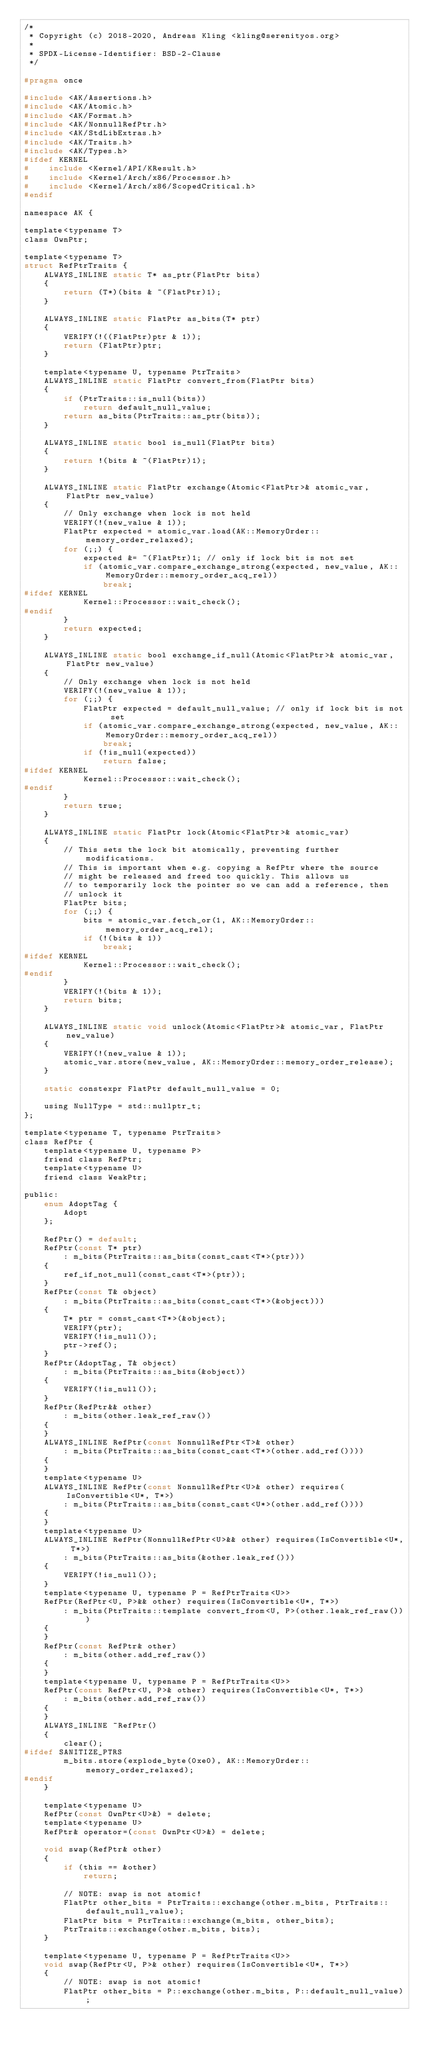Convert code to text. <code><loc_0><loc_0><loc_500><loc_500><_C_>/*
 * Copyright (c) 2018-2020, Andreas Kling <kling@serenityos.org>
 *
 * SPDX-License-Identifier: BSD-2-Clause
 */

#pragma once

#include <AK/Assertions.h>
#include <AK/Atomic.h>
#include <AK/Format.h>
#include <AK/NonnullRefPtr.h>
#include <AK/StdLibExtras.h>
#include <AK/Traits.h>
#include <AK/Types.h>
#ifdef KERNEL
#    include <Kernel/API/KResult.h>
#    include <Kernel/Arch/x86/Processor.h>
#    include <Kernel/Arch/x86/ScopedCritical.h>
#endif

namespace AK {

template<typename T>
class OwnPtr;

template<typename T>
struct RefPtrTraits {
    ALWAYS_INLINE static T* as_ptr(FlatPtr bits)
    {
        return (T*)(bits & ~(FlatPtr)1);
    }

    ALWAYS_INLINE static FlatPtr as_bits(T* ptr)
    {
        VERIFY(!((FlatPtr)ptr & 1));
        return (FlatPtr)ptr;
    }

    template<typename U, typename PtrTraits>
    ALWAYS_INLINE static FlatPtr convert_from(FlatPtr bits)
    {
        if (PtrTraits::is_null(bits))
            return default_null_value;
        return as_bits(PtrTraits::as_ptr(bits));
    }

    ALWAYS_INLINE static bool is_null(FlatPtr bits)
    {
        return !(bits & ~(FlatPtr)1);
    }

    ALWAYS_INLINE static FlatPtr exchange(Atomic<FlatPtr>& atomic_var, FlatPtr new_value)
    {
        // Only exchange when lock is not held
        VERIFY(!(new_value & 1));
        FlatPtr expected = atomic_var.load(AK::MemoryOrder::memory_order_relaxed);
        for (;;) {
            expected &= ~(FlatPtr)1; // only if lock bit is not set
            if (atomic_var.compare_exchange_strong(expected, new_value, AK::MemoryOrder::memory_order_acq_rel))
                break;
#ifdef KERNEL
            Kernel::Processor::wait_check();
#endif
        }
        return expected;
    }

    ALWAYS_INLINE static bool exchange_if_null(Atomic<FlatPtr>& atomic_var, FlatPtr new_value)
    {
        // Only exchange when lock is not held
        VERIFY(!(new_value & 1));
        for (;;) {
            FlatPtr expected = default_null_value; // only if lock bit is not set
            if (atomic_var.compare_exchange_strong(expected, new_value, AK::MemoryOrder::memory_order_acq_rel))
                break;
            if (!is_null(expected))
                return false;
#ifdef KERNEL
            Kernel::Processor::wait_check();
#endif
        }
        return true;
    }

    ALWAYS_INLINE static FlatPtr lock(Atomic<FlatPtr>& atomic_var)
    {
        // This sets the lock bit atomically, preventing further modifications.
        // This is important when e.g. copying a RefPtr where the source
        // might be released and freed too quickly. This allows us
        // to temporarily lock the pointer so we can add a reference, then
        // unlock it
        FlatPtr bits;
        for (;;) {
            bits = atomic_var.fetch_or(1, AK::MemoryOrder::memory_order_acq_rel);
            if (!(bits & 1))
                break;
#ifdef KERNEL
            Kernel::Processor::wait_check();
#endif
        }
        VERIFY(!(bits & 1));
        return bits;
    }

    ALWAYS_INLINE static void unlock(Atomic<FlatPtr>& atomic_var, FlatPtr new_value)
    {
        VERIFY(!(new_value & 1));
        atomic_var.store(new_value, AK::MemoryOrder::memory_order_release);
    }

    static constexpr FlatPtr default_null_value = 0;

    using NullType = std::nullptr_t;
};

template<typename T, typename PtrTraits>
class RefPtr {
    template<typename U, typename P>
    friend class RefPtr;
    template<typename U>
    friend class WeakPtr;

public:
    enum AdoptTag {
        Adopt
    };

    RefPtr() = default;
    RefPtr(const T* ptr)
        : m_bits(PtrTraits::as_bits(const_cast<T*>(ptr)))
    {
        ref_if_not_null(const_cast<T*>(ptr));
    }
    RefPtr(const T& object)
        : m_bits(PtrTraits::as_bits(const_cast<T*>(&object)))
    {
        T* ptr = const_cast<T*>(&object);
        VERIFY(ptr);
        VERIFY(!is_null());
        ptr->ref();
    }
    RefPtr(AdoptTag, T& object)
        : m_bits(PtrTraits::as_bits(&object))
    {
        VERIFY(!is_null());
    }
    RefPtr(RefPtr&& other)
        : m_bits(other.leak_ref_raw())
    {
    }
    ALWAYS_INLINE RefPtr(const NonnullRefPtr<T>& other)
        : m_bits(PtrTraits::as_bits(const_cast<T*>(other.add_ref())))
    {
    }
    template<typename U>
    ALWAYS_INLINE RefPtr(const NonnullRefPtr<U>& other) requires(IsConvertible<U*, T*>)
        : m_bits(PtrTraits::as_bits(const_cast<U*>(other.add_ref())))
    {
    }
    template<typename U>
    ALWAYS_INLINE RefPtr(NonnullRefPtr<U>&& other) requires(IsConvertible<U*, T*>)
        : m_bits(PtrTraits::as_bits(&other.leak_ref()))
    {
        VERIFY(!is_null());
    }
    template<typename U, typename P = RefPtrTraits<U>>
    RefPtr(RefPtr<U, P>&& other) requires(IsConvertible<U*, T*>)
        : m_bits(PtrTraits::template convert_from<U, P>(other.leak_ref_raw()))
    {
    }
    RefPtr(const RefPtr& other)
        : m_bits(other.add_ref_raw())
    {
    }
    template<typename U, typename P = RefPtrTraits<U>>
    RefPtr(const RefPtr<U, P>& other) requires(IsConvertible<U*, T*>)
        : m_bits(other.add_ref_raw())
    {
    }
    ALWAYS_INLINE ~RefPtr()
    {
        clear();
#ifdef SANITIZE_PTRS
        m_bits.store(explode_byte(0xe0), AK::MemoryOrder::memory_order_relaxed);
#endif
    }

    template<typename U>
    RefPtr(const OwnPtr<U>&) = delete;
    template<typename U>
    RefPtr& operator=(const OwnPtr<U>&) = delete;

    void swap(RefPtr& other)
    {
        if (this == &other)
            return;

        // NOTE: swap is not atomic!
        FlatPtr other_bits = PtrTraits::exchange(other.m_bits, PtrTraits::default_null_value);
        FlatPtr bits = PtrTraits::exchange(m_bits, other_bits);
        PtrTraits::exchange(other.m_bits, bits);
    }

    template<typename U, typename P = RefPtrTraits<U>>
    void swap(RefPtr<U, P>& other) requires(IsConvertible<U*, T*>)
    {
        // NOTE: swap is not atomic!
        FlatPtr other_bits = P::exchange(other.m_bits, P::default_null_value);</code> 